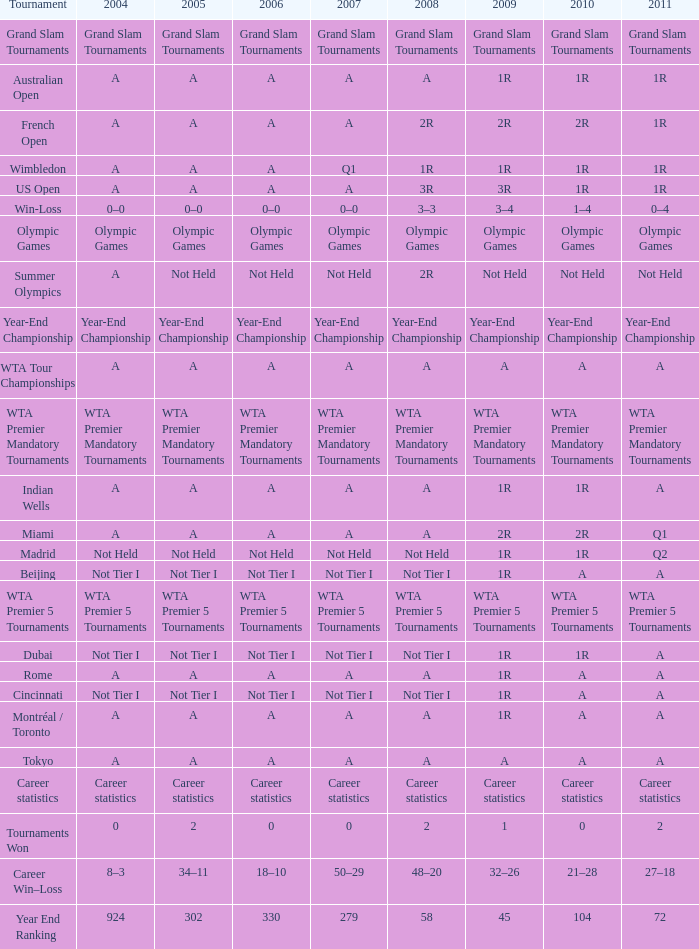What is 2004, when 2008 is "WTA Premier 5 Tournaments"? WTA Premier 5 Tournaments. 